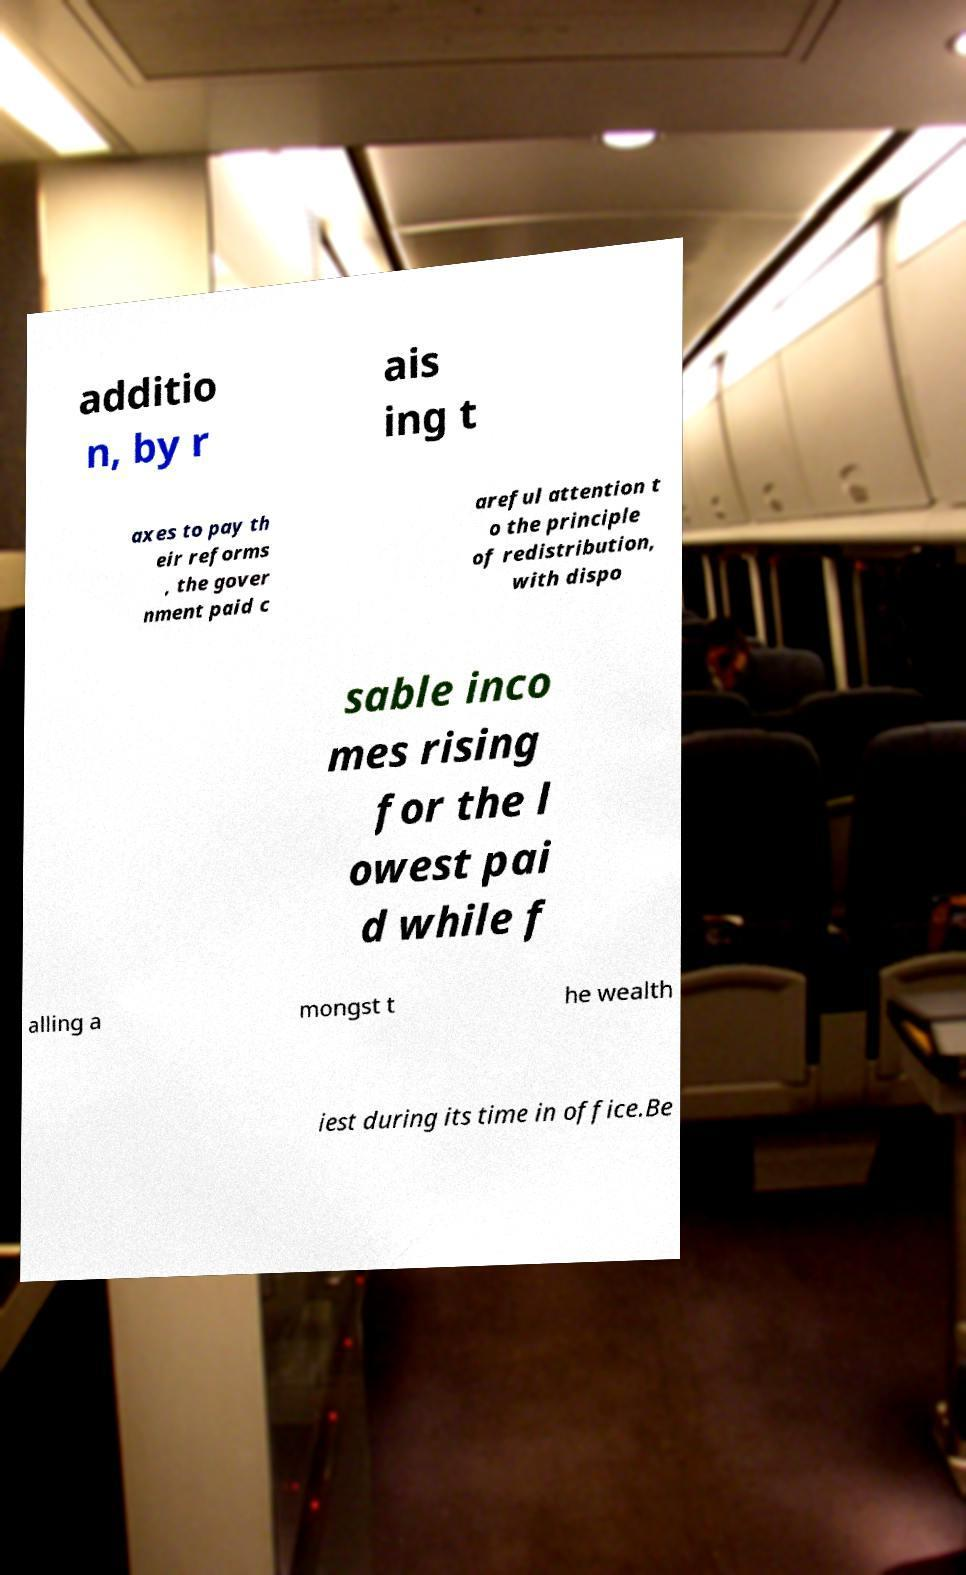For documentation purposes, I need the text within this image transcribed. Could you provide that? additio n, by r ais ing t axes to pay th eir reforms , the gover nment paid c areful attention t o the principle of redistribution, with dispo sable inco mes rising for the l owest pai d while f alling a mongst t he wealth iest during its time in office.Be 